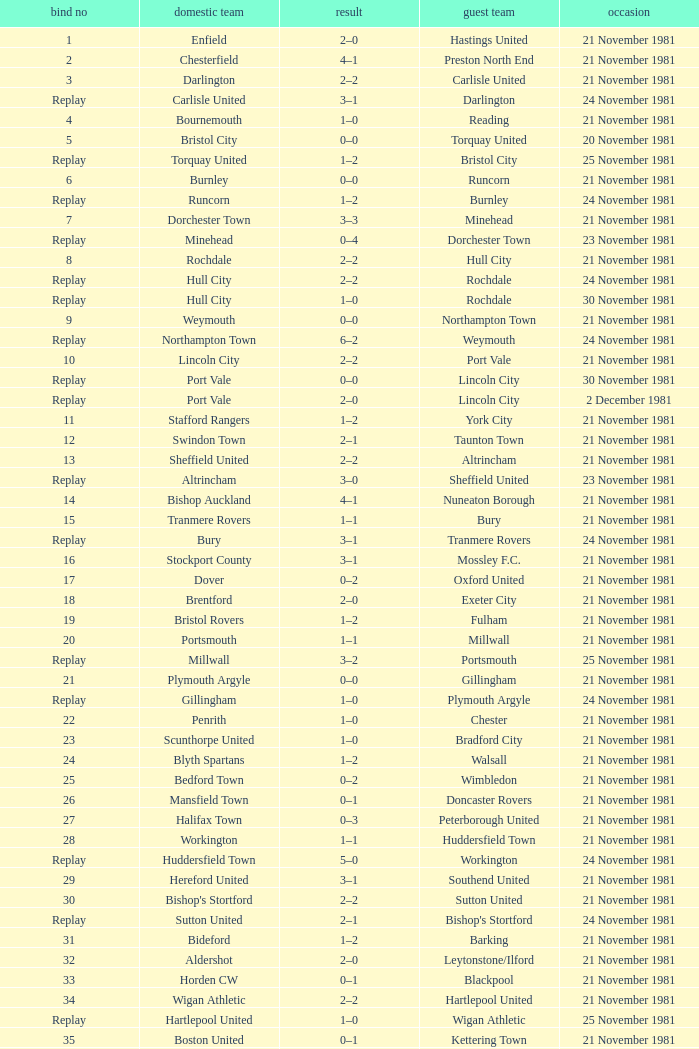What is enfield's tie number? 1.0. 